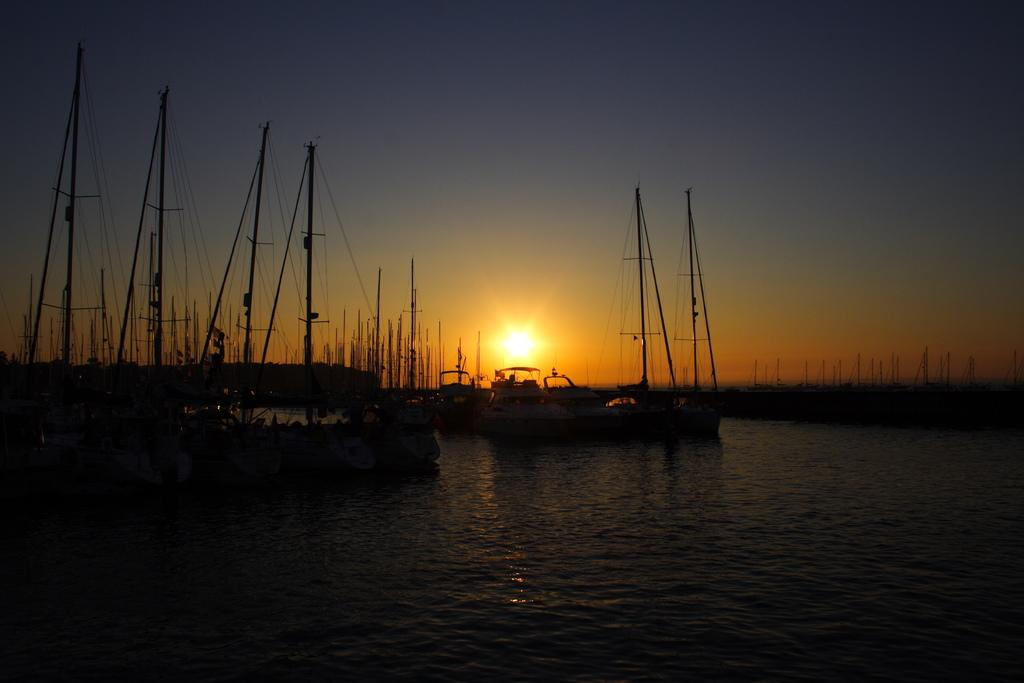What type of vehicles are in the image? There are boats in the image. Where are the boats located? The boats are on water. What can be seen in the background of the image? The sky is visible in the background of the image. What type of dress is the manager wearing in the image? There is no manager or dress present in the image; it features boats on water with the sky visible in the background. 